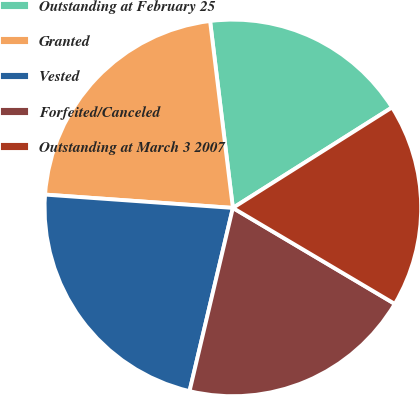<chart> <loc_0><loc_0><loc_500><loc_500><pie_chart><fcel>Outstanding at February 25<fcel>Granted<fcel>Vested<fcel>Forfeited/Canceled<fcel>Outstanding at March 3 2007<nl><fcel>17.97%<fcel>21.94%<fcel>22.43%<fcel>20.18%<fcel>17.48%<nl></chart> 